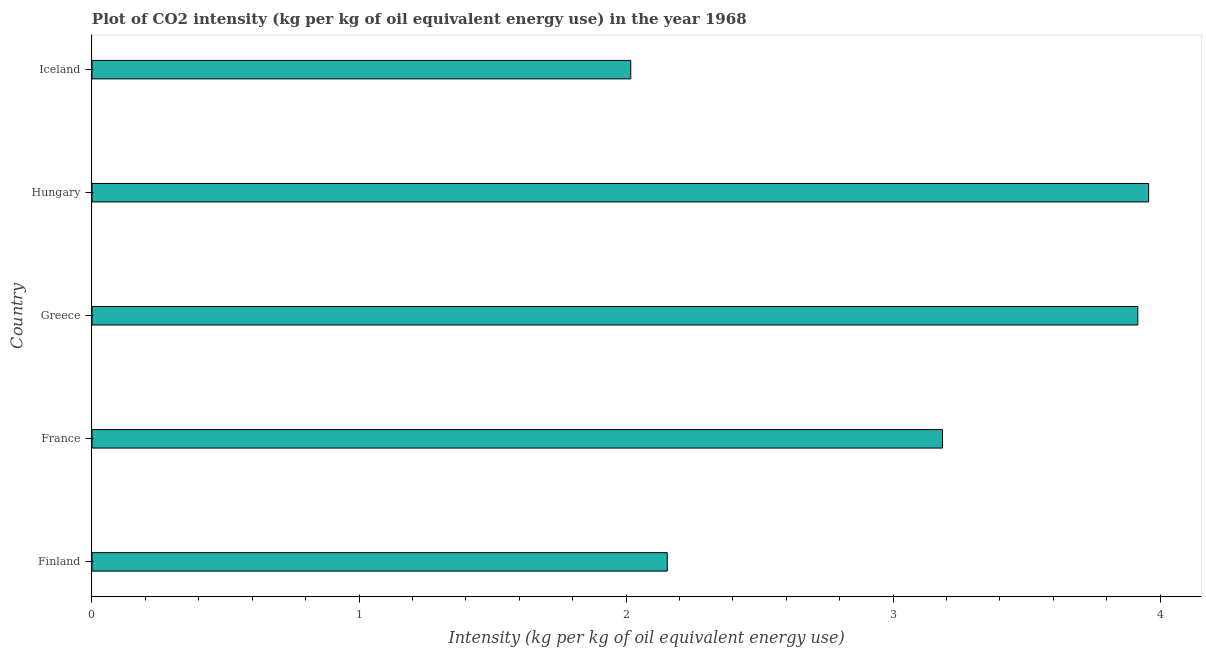Does the graph contain any zero values?
Your response must be concise. No. Does the graph contain grids?
Offer a very short reply. No. What is the title of the graph?
Give a very brief answer. Plot of CO2 intensity (kg per kg of oil equivalent energy use) in the year 1968. What is the label or title of the X-axis?
Offer a terse response. Intensity (kg per kg of oil equivalent energy use). What is the label or title of the Y-axis?
Provide a succinct answer. Country. What is the co2 intensity in Hungary?
Provide a short and direct response. 3.96. Across all countries, what is the maximum co2 intensity?
Your response must be concise. 3.96. Across all countries, what is the minimum co2 intensity?
Keep it short and to the point. 2.02. In which country was the co2 intensity maximum?
Provide a succinct answer. Hungary. In which country was the co2 intensity minimum?
Keep it short and to the point. Iceland. What is the sum of the co2 intensity?
Provide a short and direct response. 15.23. What is the difference between the co2 intensity in Finland and Iceland?
Offer a terse response. 0.14. What is the average co2 intensity per country?
Provide a short and direct response. 3.05. What is the median co2 intensity?
Your response must be concise. 3.18. In how many countries, is the co2 intensity greater than 1.8 kg?
Provide a short and direct response. 5. What is the ratio of the co2 intensity in Finland to that in Iceland?
Provide a succinct answer. 1.07. Is the difference between the co2 intensity in Hungary and Iceland greater than the difference between any two countries?
Provide a succinct answer. Yes. What is the difference between the highest and the second highest co2 intensity?
Offer a very short reply. 0.04. What is the difference between the highest and the lowest co2 intensity?
Keep it short and to the point. 1.94. How many bars are there?
Provide a short and direct response. 5. Are all the bars in the graph horizontal?
Provide a short and direct response. Yes. How many countries are there in the graph?
Your response must be concise. 5. What is the difference between two consecutive major ticks on the X-axis?
Your answer should be compact. 1. Are the values on the major ticks of X-axis written in scientific E-notation?
Make the answer very short. No. What is the Intensity (kg per kg of oil equivalent energy use) of Finland?
Give a very brief answer. 2.15. What is the Intensity (kg per kg of oil equivalent energy use) in France?
Your response must be concise. 3.18. What is the Intensity (kg per kg of oil equivalent energy use) in Greece?
Your answer should be very brief. 3.92. What is the Intensity (kg per kg of oil equivalent energy use) in Hungary?
Offer a terse response. 3.96. What is the Intensity (kg per kg of oil equivalent energy use) of Iceland?
Make the answer very short. 2.02. What is the difference between the Intensity (kg per kg of oil equivalent energy use) in Finland and France?
Keep it short and to the point. -1.03. What is the difference between the Intensity (kg per kg of oil equivalent energy use) in Finland and Greece?
Give a very brief answer. -1.76. What is the difference between the Intensity (kg per kg of oil equivalent energy use) in Finland and Hungary?
Make the answer very short. -1.8. What is the difference between the Intensity (kg per kg of oil equivalent energy use) in Finland and Iceland?
Offer a very short reply. 0.14. What is the difference between the Intensity (kg per kg of oil equivalent energy use) in France and Greece?
Offer a very short reply. -0.73. What is the difference between the Intensity (kg per kg of oil equivalent energy use) in France and Hungary?
Make the answer very short. -0.77. What is the difference between the Intensity (kg per kg of oil equivalent energy use) in France and Iceland?
Offer a very short reply. 1.17. What is the difference between the Intensity (kg per kg of oil equivalent energy use) in Greece and Hungary?
Keep it short and to the point. -0.04. What is the difference between the Intensity (kg per kg of oil equivalent energy use) in Greece and Iceland?
Your answer should be compact. 1.9. What is the difference between the Intensity (kg per kg of oil equivalent energy use) in Hungary and Iceland?
Keep it short and to the point. 1.94. What is the ratio of the Intensity (kg per kg of oil equivalent energy use) in Finland to that in France?
Give a very brief answer. 0.68. What is the ratio of the Intensity (kg per kg of oil equivalent energy use) in Finland to that in Greece?
Your answer should be compact. 0.55. What is the ratio of the Intensity (kg per kg of oil equivalent energy use) in Finland to that in Hungary?
Provide a short and direct response. 0.54. What is the ratio of the Intensity (kg per kg of oil equivalent energy use) in Finland to that in Iceland?
Your answer should be very brief. 1.07. What is the ratio of the Intensity (kg per kg of oil equivalent energy use) in France to that in Greece?
Your answer should be compact. 0.81. What is the ratio of the Intensity (kg per kg of oil equivalent energy use) in France to that in Hungary?
Ensure brevity in your answer.  0.81. What is the ratio of the Intensity (kg per kg of oil equivalent energy use) in France to that in Iceland?
Provide a succinct answer. 1.58. What is the ratio of the Intensity (kg per kg of oil equivalent energy use) in Greece to that in Hungary?
Offer a very short reply. 0.99. What is the ratio of the Intensity (kg per kg of oil equivalent energy use) in Greece to that in Iceland?
Your answer should be compact. 1.94. What is the ratio of the Intensity (kg per kg of oil equivalent energy use) in Hungary to that in Iceland?
Your answer should be compact. 1.96. 